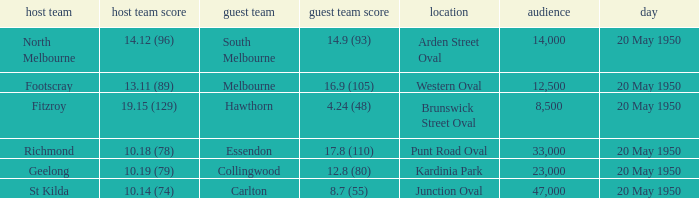What was the date of the game when the away team was south melbourne? 20 May 1950. I'm looking to parse the entire table for insights. Could you assist me with that? {'header': ['host team', 'host team score', 'guest team', 'guest team score', 'location', 'audience', 'day'], 'rows': [['North Melbourne', '14.12 (96)', 'South Melbourne', '14.9 (93)', 'Arden Street Oval', '14,000', '20 May 1950'], ['Footscray', '13.11 (89)', 'Melbourne', '16.9 (105)', 'Western Oval', '12,500', '20 May 1950'], ['Fitzroy', '19.15 (129)', 'Hawthorn', '4.24 (48)', 'Brunswick Street Oval', '8,500', '20 May 1950'], ['Richmond', '10.18 (78)', 'Essendon', '17.8 (110)', 'Punt Road Oval', '33,000', '20 May 1950'], ['Geelong', '10.19 (79)', 'Collingwood', '12.8 (80)', 'Kardinia Park', '23,000', '20 May 1950'], ['St Kilda', '10.14 (74)', 'Carlton', '8.7 (55)', 'Junction Oval', '47,000', '20 May 1950']]} 